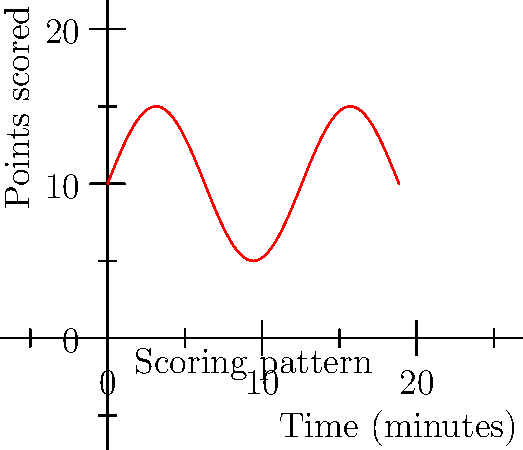During a crucial game, the Gators' scoring pattern followed the curve shown above, representing points scored over time. If the game lasted for 30 minutes (equivalent to $6\pi$ on the x-axis), what was the total area under the curve, representing the cumulative scoring potential? To find the area under the curve, we need to integrate the function over the given interval. The steps are:

1) The function representing the curve is $f(x) = 5\sin(\frac{x}{2}) + 10$

2) We need to integrate this function from 0 to $6\pi$:

   $$\int_0^{6\pi} (5\sin(\frac{x}{2}) + 10) dx$$

3) Let's split this into two integrals:

   $$\int_0^{6\pi} 5\sin(\frac{x}{2}) dx + \int_0^{6\pi} 10 dx$$

4) For the first integral, we can use substitution. Let $u = \frac{x}{2}$, then $du = \frac{1}{2}dx$ or $dx = 2du$:

   $$10\int_0^{3\pi} \sin(u) du + 10(6\pi)$$

5) Evaluating the sine integral:

   $$10[-\cos(u)]_0^{3\pi} + 60\pi$$

6) This simplifies to:

   $$10(-\cos(3\pi) + \cos(0)) + 60\pi = 10(-(-1) + 1) + 60\pi = 20 + 60\pi$$

7) Therefore, the total area under the curve is $20 + 60\pi$ square units.
Answer: $20 + 60\pi$ square units 